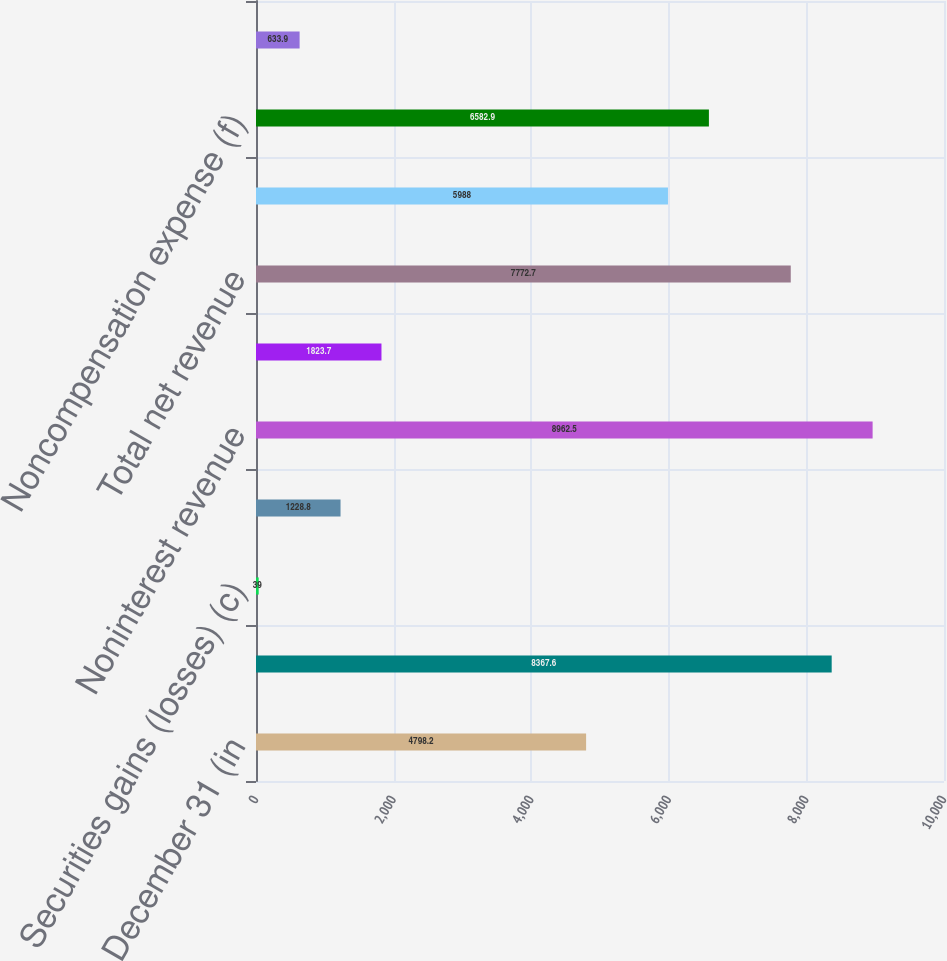Convert chart. <chart><loc_0><loc_0><loc_500><loc_500><bar_chart><fcel>Year ended December 31 (in<fcel>Principal transactions (a)(b)<fcel>Securities gains (losses) (c)<fcel>All other income (d)<fcel>Noninterest revenue<fcel>Net interest income (expense)<fcel>Total net revenue<fcel>Compensation expense<fcel>Noncompensation expense (f)<fcel>Merger costs<nl><fcel>4798.2<fcel>8367.6<fcel>39<fcel>1228.8<fcel>8962.5<fcel>1823.7<fcel>7772.7<fcel>5988<fcel>6582.9<fcel>633.9<nl></chart> 